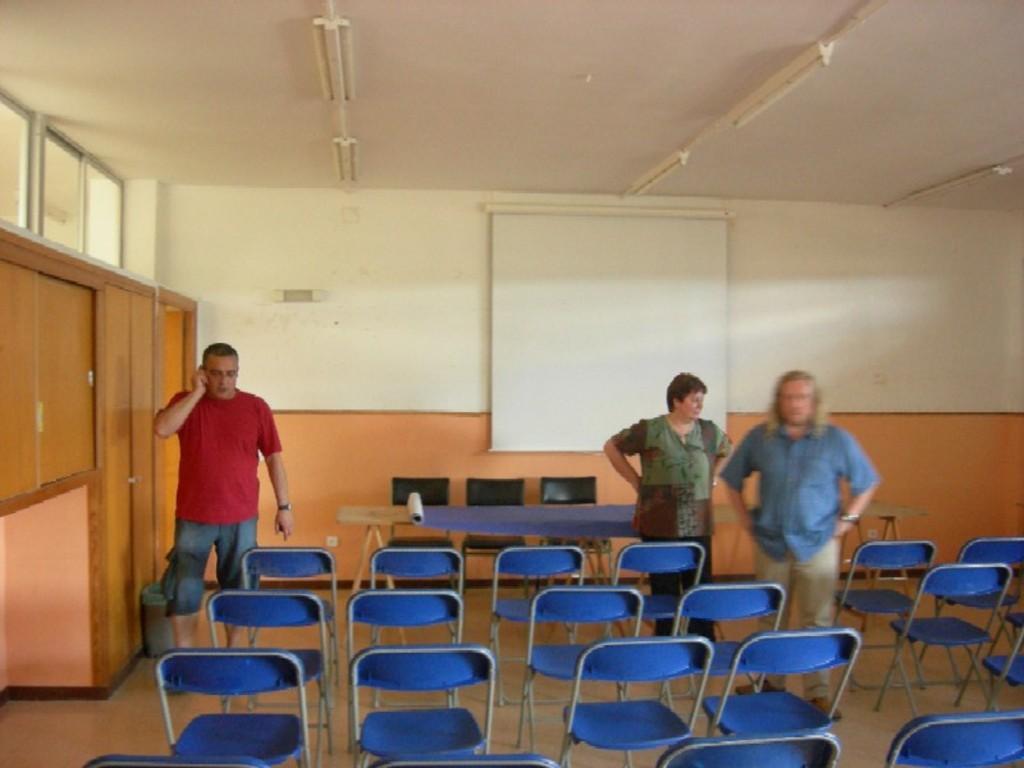How would you summarize this image in a sentence or two? On the left side, there is a person in red color t-shirt, holding mobile and speaking and standing on the floor, on which, there are blue color chairs arranged. On the right side, there are two persons standing on the floor. In the background, there is a table, on which, there is a blue color sheet. Beside this table, there are chairs arranged, there is a white color screen on the wall, there are lights arranged on the roof, there are glass windows and cupboards. 